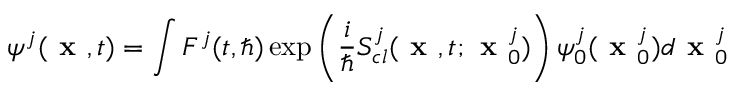Convert formula to latex. <formula><loc_0><loc_0><loc_500><loc_500>\psi ^ { j } ( x , t ) = \int F ^ { j } ( t , \hbar { ) } \exp \left ( \frac { i } { } S _ { c l } ^ { j } ( x , t ; x _ { 0 } ^ { j } ) \right ) \psi _ { 0 } ^ { j } ( x _ { 0 } ^ { j } ) d x _ { 0 } ^ { j }</formula> 